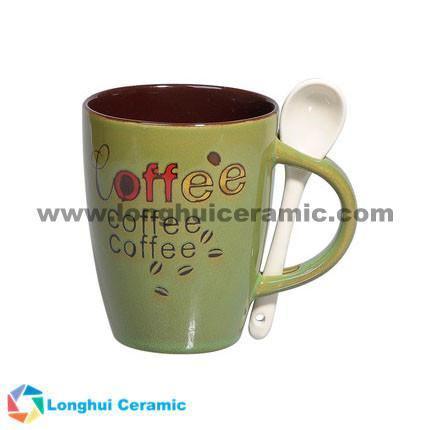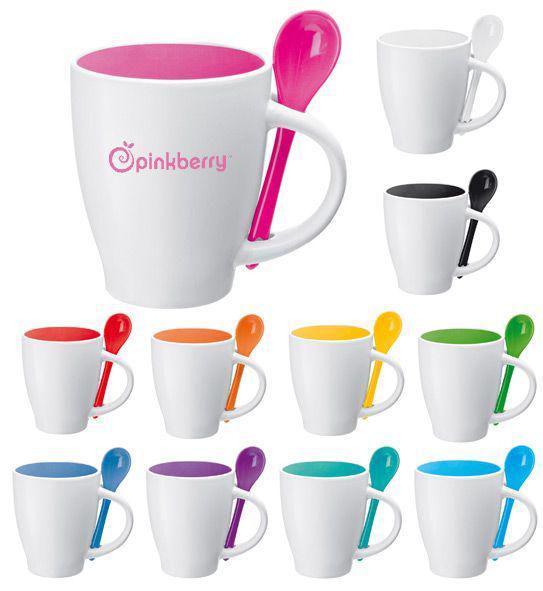The first image is the image on the left, the second image is the image on the right. For the images displayed, is the sentence "One image shows a single blue-lined white cup with a blue spoon." factually correct? Answer yes or no. No. 